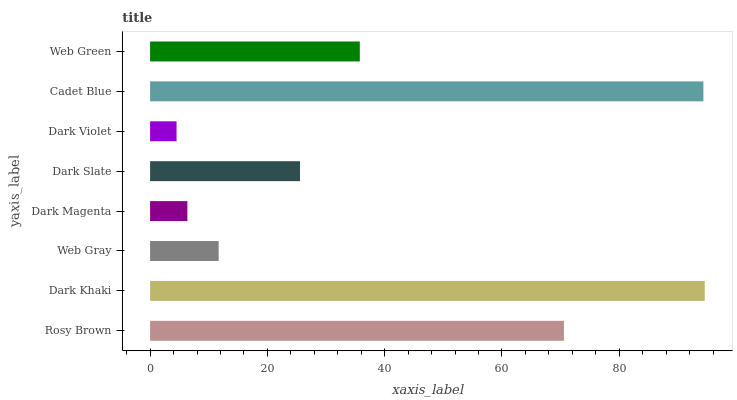Is Dark Violet the minimum?
Answer yes or no. Yes. Is Dark Khaki the maximum?
Answer yes or no. Yes. Is Web Gray the minimum?
Answer yes or no. No. Is Web Gray the maximum?
Answer yes or no. No. Is Dark Khaki greater than Web Gray?
Answer yes or no. Yes. Is Web Gray less than Dark Khaki?
Answer yes or no. Yes. Is Web Gray greater than Dark Khaki?
Answer yes or no. No. Is Dark Khaki less than Web Gray?
Answer yes or no. No. Is Web Green the high median?
Answer yes or no. Yes. Is Dark Slate the low median?
Answer yes or no. Yes. Is Dark Magenta the high median?
Answer yes or no. No. Is Web Green the low median?
Answer yes or no. No. 